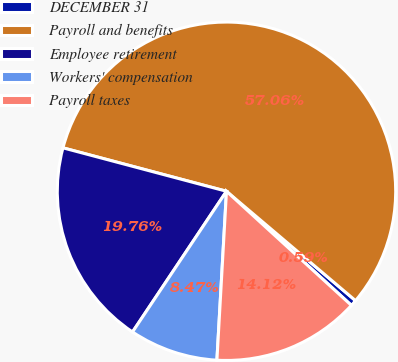<chart> <loc_0><loc_0><loc_500><loc_500><pie_chart><fcel>DECEMBER 31<fcel>Payroll and benefits<fcel>Employee retirement<fcel>Workers' compensation<fcel>Payroll taxes<nl><fcel>0.59%<fcel>57.06%<fcel>19.76%<fcel>8.47%<fcel>14.12%<nl></chart> 